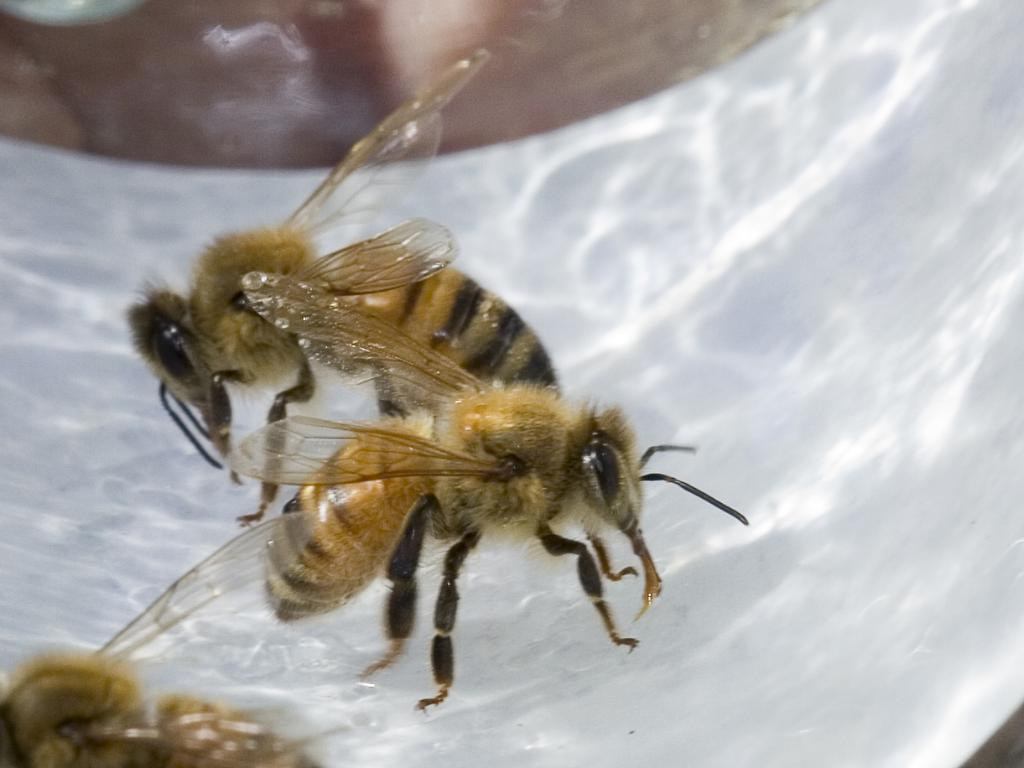What is located in the center of the image? There are bees in the center of the image. What can be seen at the bottom of the image? There is a white substance at the bottom of the image. What type of statement is being made by the bees in the image? There is no statement being made by the bees in the image; they are simply present in the center. How is the cork used in the image? There is no cork present in the image. What type of cake is visible in the image? There is no cake present in the image. 